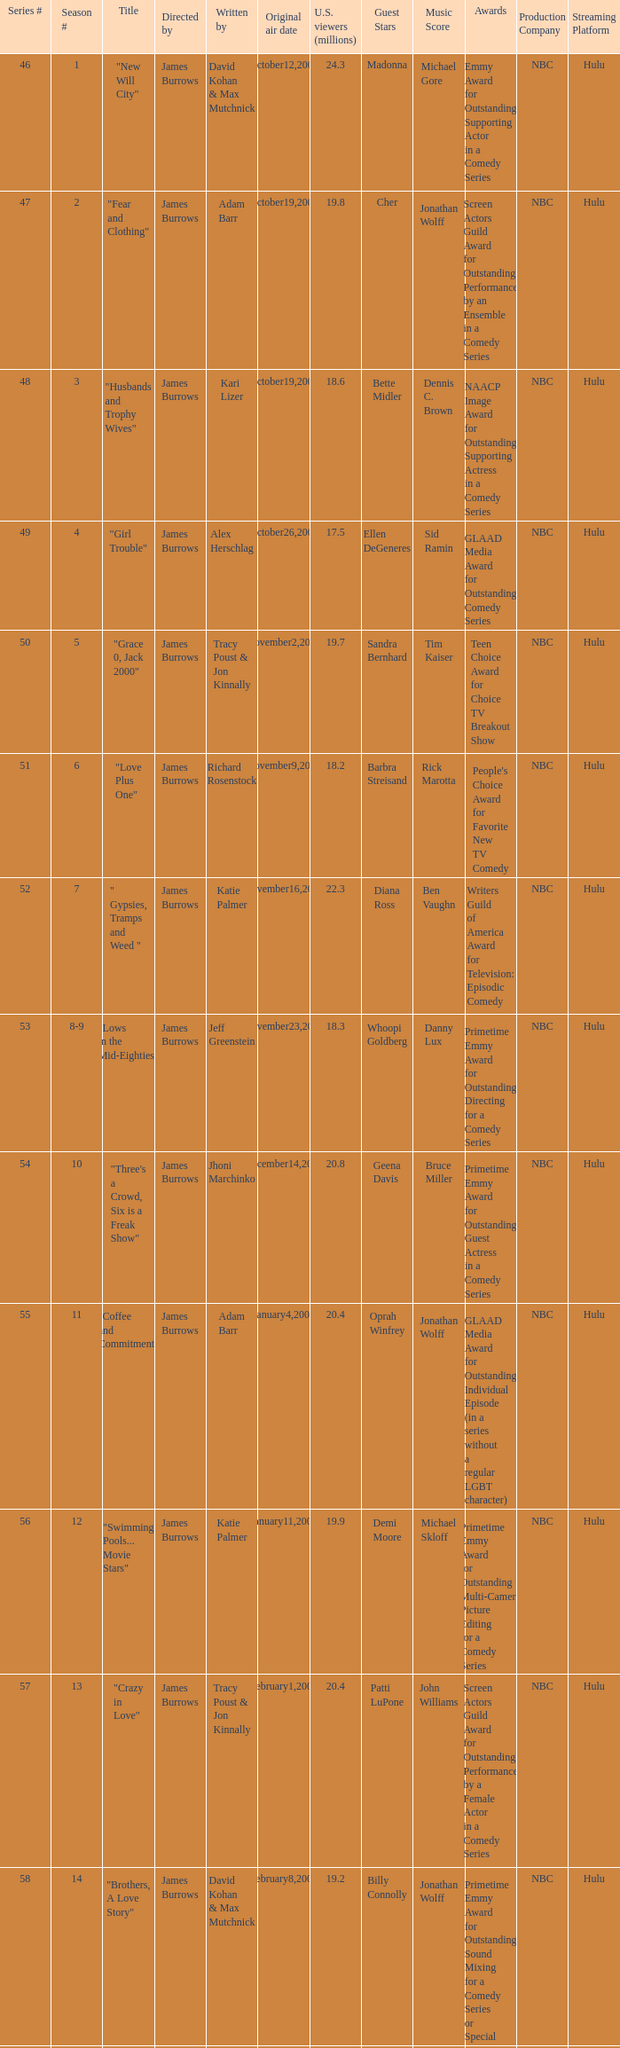Who wrote episode 23 in the season? Kari Lizer. 